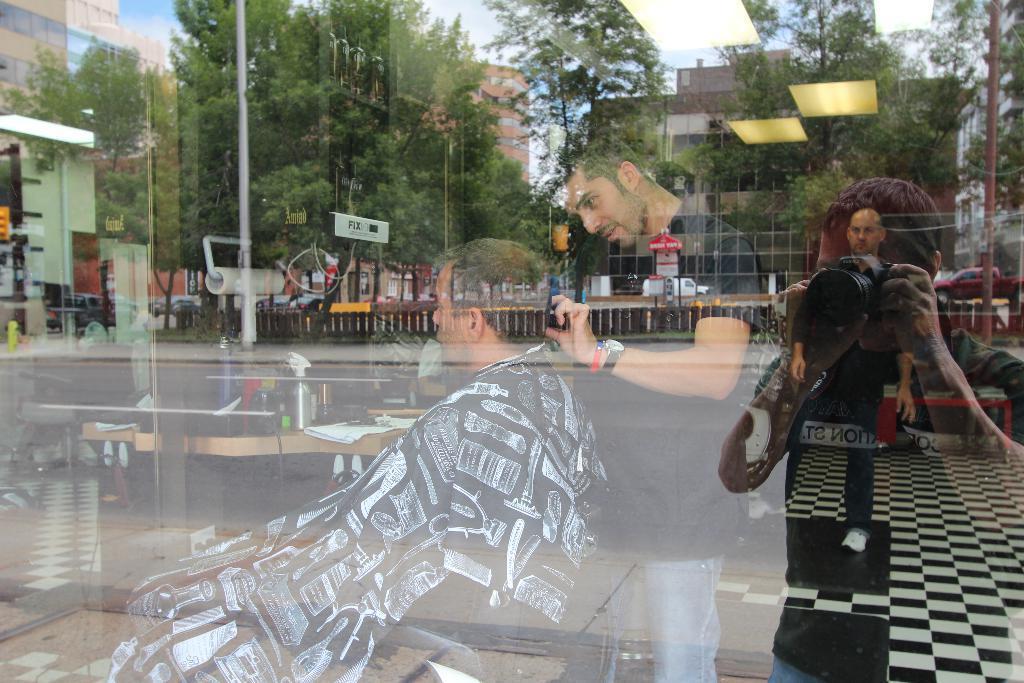Could you give a brief overview of what you see in this image? In this picture I can see a man sitting, there is a person standing and doing something, there are some objects on the table. On the transparent glass there is a reflection of a person standing and holding a camera, there is fence, road, there are buildings, trees and the sky. 